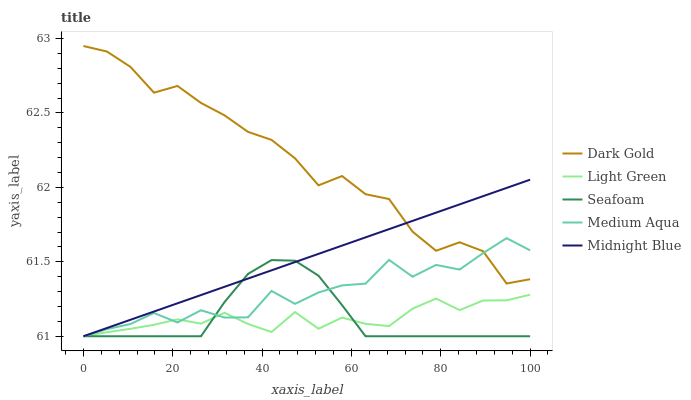Does Seafoam have the minimum area under the curve?
Answer yes or no. Yes. Does Dark Gold have the maximum area under the curve?
Answer yes or no. Yes. Does Medium Aqua have the minimum area under the curve?
Answer yes or no. No. Does Medium Aqua have the maximum area under the curve?
Answer yes or no. No. Is Midnight Blue the smoothest?
Answer yes or no. Yes. Is Dark Gold the roughest?
Answer yes or no. Yes. Is Medium Aqua the smoothest?
Answer yes or no. No. Is Medium Aqua the roughest?
Answer yes or no. No. Does Midnight Blue have the lowest value?
Answer yes or no. Yes. Does Dark Gold have the lowest value?
Answer yes or no. No. Does Dark Gold have the highest value?
Answer yes or no. Yes. Does Medium Aqua have the highest value?
Answer yes or no. No. Is Light Green less than Dark Gold?
Answer yes or no. Yes. Is Dark Gold greater than Light Green?
Answer yes or no. Yes. Does Midnight Blue intersect Light Green?
Answer yes or no. Yes. Is Midnight Blue less than Light Green?
Answer yes or no. No. Is Midnight Blue greater than Light Green?
Answer yes or no. No. Does Light Green intersect Dark Gold?
Answer yes or no. No. 